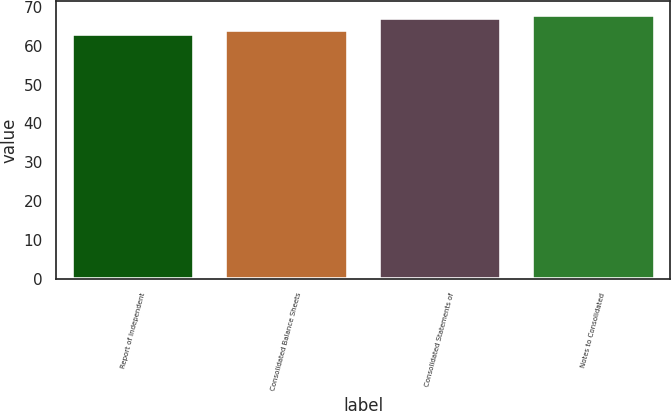Convert chart to OTSL. <chart><loc_0><loc_0><loc_500><loc_500><bar_chart><fcel>Report of Independent<fcel>Consolidated Balance Sheets<fcel>Consolidated Statements of<fcel>Notes to Consolidated<nl><fcel>63<fcel>64<fcel>67<fcel>68<nl></chart> 